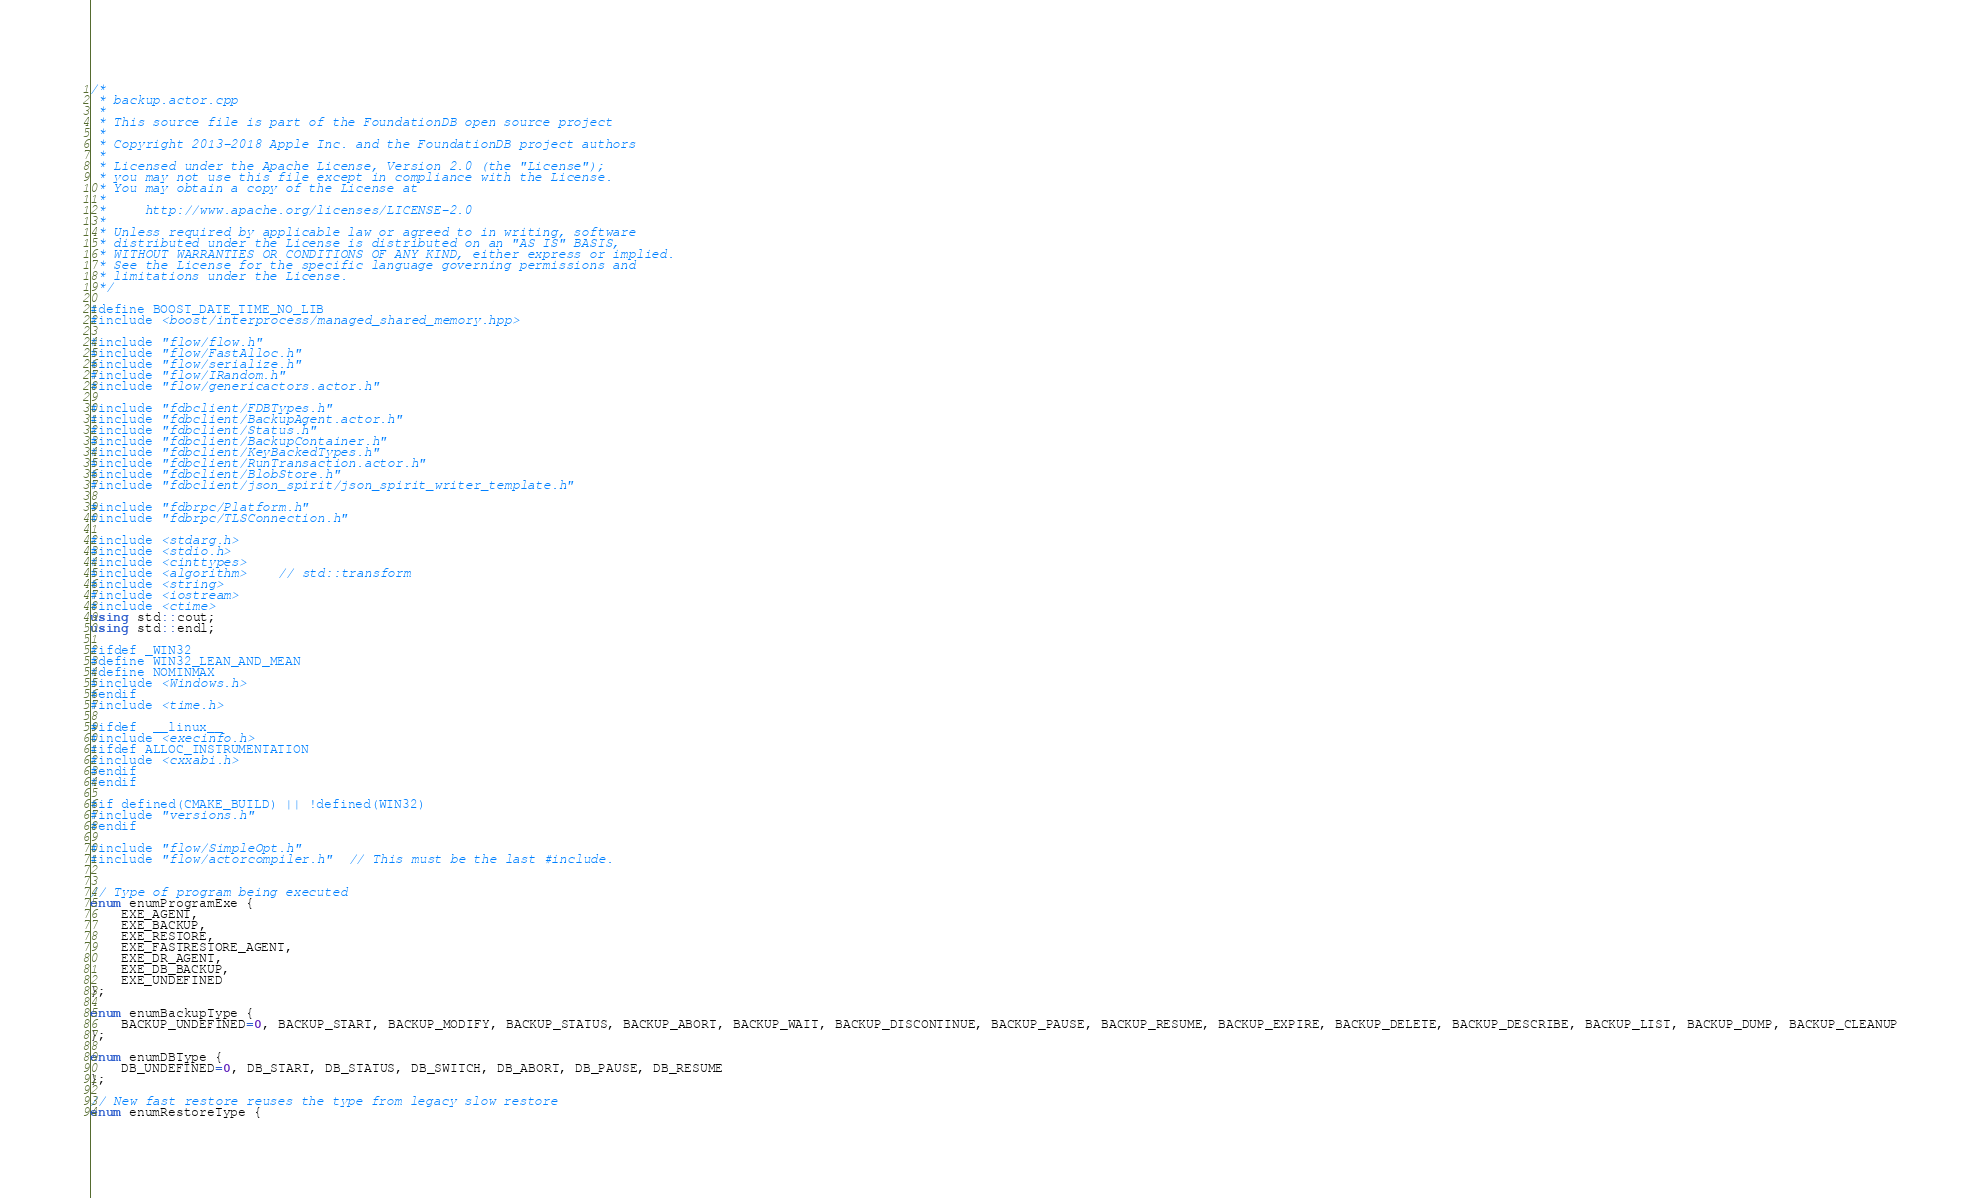<code> <loc_0><loc_0><loc_500><loc_500><_C++_>/*
 * backup.actor.cpp
 *
 * This source file is part of the FoundationDB open source project
 *
 * Copyright 2013-2018 Apple Inc. and the FoundationDB project authors
 *
 * Licensed under the Apache License, Version 2.0 (the "License");
 * you may not use this file except in compliance with the License.
 * You may obtain a copy of the License at
 *
 *     http://www.apache.org/licenses/LICENSE-2.0
 *
 * Unless required by applicable law or agreed to in writing, software
 * distributed under the License is distributed on an "AS IS" BASIS,
 * WITHOUT WARRANTIES OR CONDITIONS OF ANY KIND, either express or implied.
 * See the License for the specific language governing permissions and
 * limitations under the License.
 */

#define BOOST_DATE_TIME_NO_LIB
#include <boost/interprocess/managed_shared_memory.hpp>

#include "flow/flow.h"
#include "flow/FastAlloc.h"
#include "flow/serialize.h"
#include "flow/IRandom.h"
#include "flow/genericactors.actor.h"

#include "fdbclient/FDBTypes.h"
#include "fdbclient/BackupAgent.actor.h"
#include "fdbclient/Status.h"
#include "fdbclient/BackupContainer.h"
#include "fdbclient/KeyBackedTypes.h"
#include "fdbclient/RunTransaction.actor.h"
#include "fdbclient/BlobStore.h"
#include "fdbclient/json_spirit/json_spirit_writer_template.h"

#include "fdbrpc/Platform.h"
#include "fdbrpc/TLSConnection.h"

#include <stdarg.h>
#include <stdio.h>
#include <cinttypes>
#include <algorithm>	// std::transform
#include <string>
#include <iostream>
#include <ctime>
using std::cout;
using std::endl;

#ifdef _WIN32
#define WIN32_LEAN_AND_MEAN
#define NOMINMAX
#include <Windows.h>
#endif
#include <time.h>

#ifdef  __linux__
#include <execinfo.h>
#ifdef ALLOC_INSTRUMENTATION
#include <cxxabi.h>
#endif
#endif

#if defined(CMAKE_BUILD) || !defined(WIN32)
#include "versions.h"
#endif

#include "flow/SimpleOpt.h"
#include "flow/actorcompiler.h"  // This must be the last #include.


// Type of program being executed
enum enumProgramExe {
	EXE_AGENT,
	EXE_BACKUP,
	EXE_RESTORE,
	EXE_FASTRESTORE_AGENT,
	EXE_DR_AGENT,
	EXE_DB_BACKUP,
	EXE_UNDEFINED
};

enum enumBackupType {
	BACKUP_UNDEFINED=0, BACKUP_START, BACKUP_MODIFY, BACKUP_STATUS, BACKUP_ABORT, BACKUP_WAIT, BACKUP_DISCONTINUE, BACKUP_PAUSE, BACKUP_RESUME, BACKUP_EXPIRE, BACKUP_DELETE, BACKUP_DESCRIBE, BACKUP_LIST, BACKUP_DUMP, BACKUP_CLEANUP
};

enum enumDBType {
	DB_UNDEFINED=0, DB_START, DB_STATUS, DB_SWITCH, DB_ABORT, DB_PAUSE, DB_RESUME
};

// New fast restore reuses the type from legacy slow restore
enum enumRestoreType {</code> 